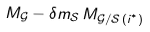<formula> <loc_0><loc_0><loc_500><loc_500>M _ { \mathcal { G } } - { \delta m } _ { \mathcal { S } } \, M _ { \mathcal { G } / \mathcal { S } \, ( i ^ { ^ { * } } ) }</formula> 